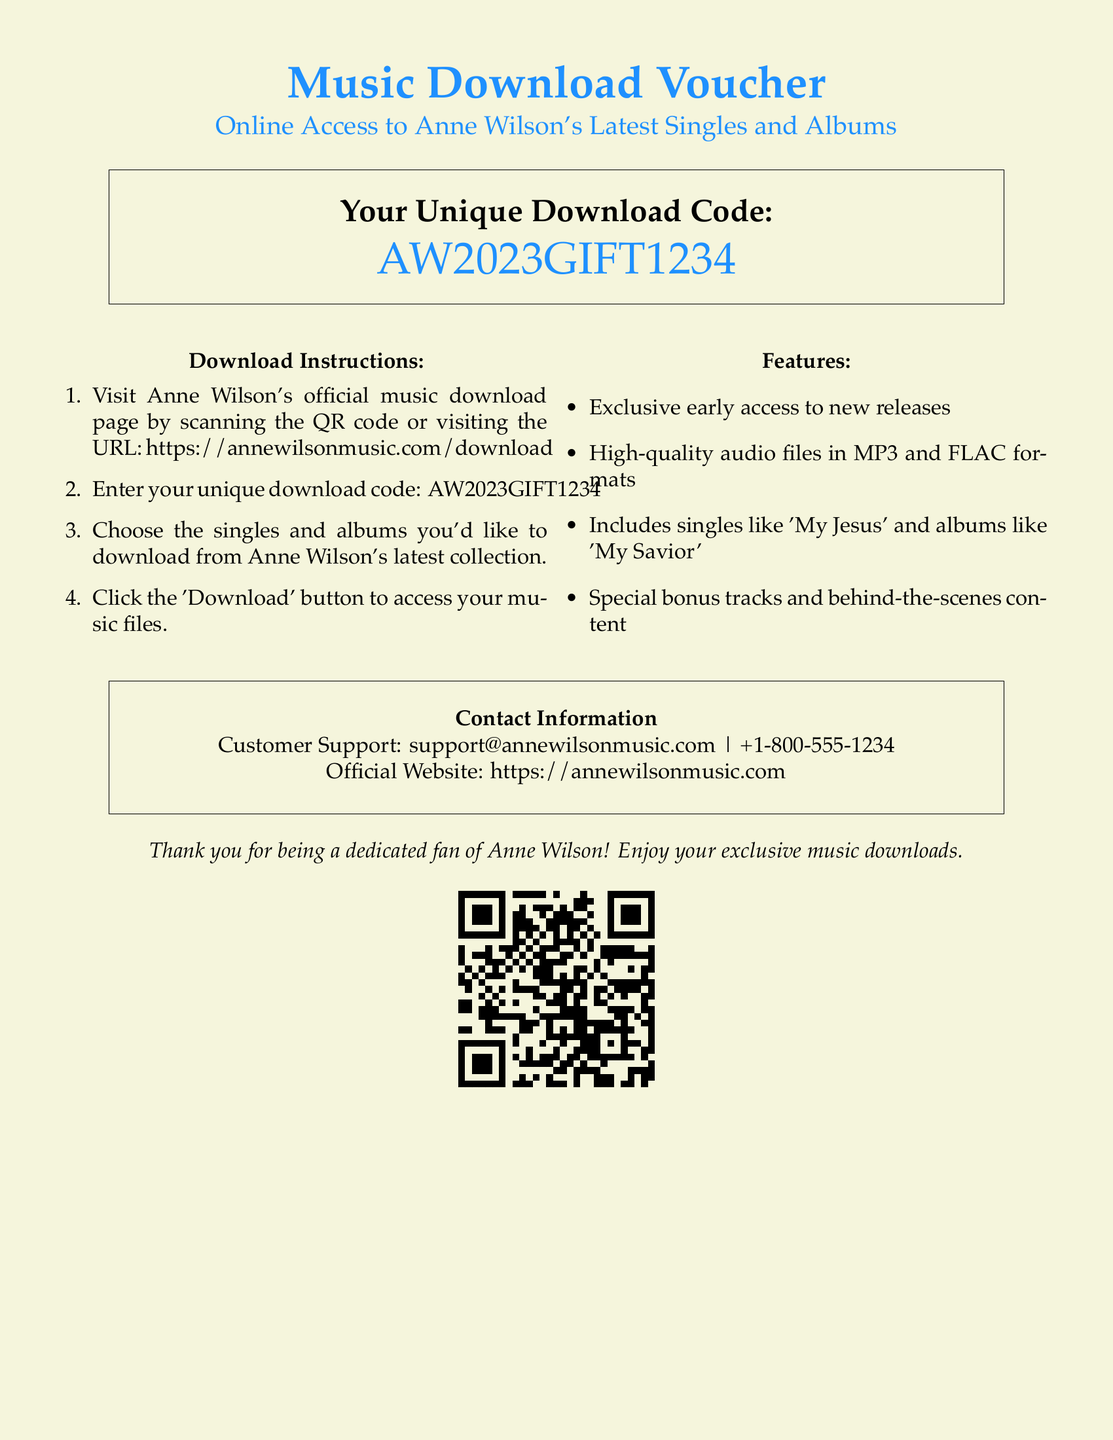What is the title of the voucher? The title of the voucher is stated at the top of the document.
Answer: Music Download Voucher What is the unique download code? The unique download code is prominently displayed in a box in the document.
Answer: AW2023GIFT1234 What website should you visit for downloads? The website for music downloads is provided in the instructions.
Answer: https://annewilsonmusic.com/download Which format is used for high-quality audio files? The document specifies the types of audio files available for download.
Answer: MP3 and FLAC What is one of the singles included in the collection? The document mentions a specific single as an example of what's included.
Answer: My Jesus What is the customer support email listed? The email address for customer support is provided at the bottom of the document.
Answer: support@annewilsonmusic.com What type of content is included besides music? The document mentions additional types of content that can be accessed.
Answer: Bonus tracks and behind-the-scenes content How many steps are in the download instructions? The download instructions are numbered, indicating the total steps.
Answer: Four steps Why are fans encouraged to use this voucher? The voucher is aimed at dedicated fans which is mentioned at the end.
Answer: Exclusive music downloads 